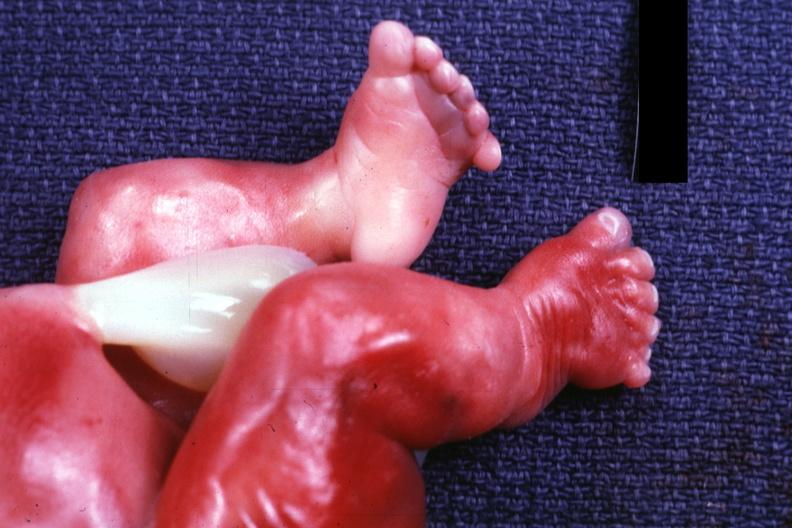do feet appear clubbed?
Answer the question using a single word or phrase. Yes 